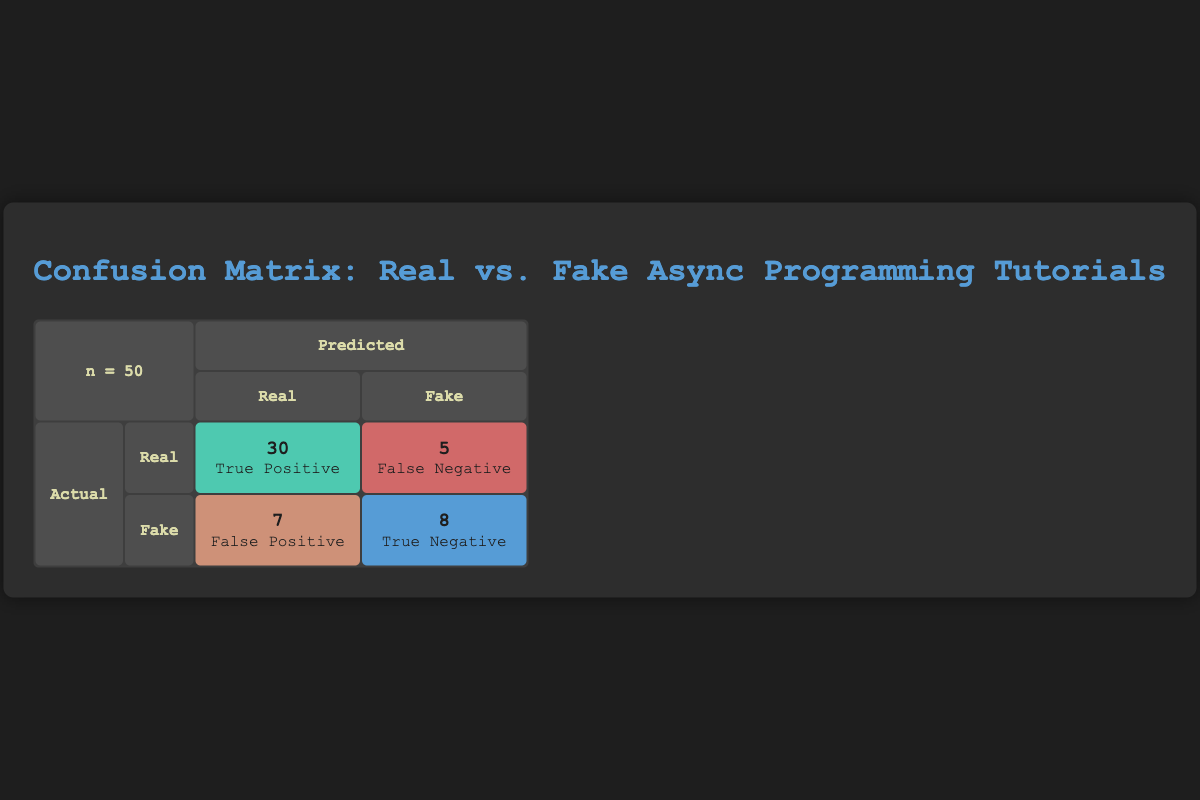What is the number of true positives in the confusion matrix? The table indicates the count of true positives is located in the cell where the actual value is "Real" and the predicted value is also "Real." This cell shows a value of 30.
Answer: 30 What is the number of false negatives? The number of false negatives is found in the cell where the actual value is "Real" but the predicted value is "Fake." The table lists this value as 5.
Answer: 5 What are the total actual fake tutorials? The total number of actual fake tutorials can be calculated by adding the true negatives (8) to the false positives (7) found in the corresponding row for "Fake." Therefore, 8 + 7 = 15.
Answer: 15 Is the number of true negatives greater than the number of false positives? The table shows 8 true negatives and 7 false positives. Since 8 is greater than 7, the statement is true.
Answer: Yes What percentage of actual real tutorials were correctly predicted? The percentage of correctly predicted real tutorials is calculated by taking the number of true positives (30) divided by the total actual real tutorials, which is 35. Thus the calculation is (30/35) * 100 = 85.71%.
Answer: 85.71% What is the total number of tutorials predicted as fake? To find the total predicted as fake, we sum the false positives (7) and true negatives (8) in the row for predicted "Fake." Therefore, the total is 7 + 8 = 15.
Answer: 15 How many tutorials were incorrectly classified as real? The number of incorrectly classified real tutorials includes the false negatives (5) alongside the false positives (7) since these represent misclassified cases. Thus the sum is 5 + 7 = 12.
Answer: 12 What fraction of the total tutorials were true positives? The total number of tutorials is 50 (sum of all values in the table). The number of true positives is 30. Therefore, the fraction is 30/50, which simplifies to 3/5.
Answer: 3/5 What is the ratio of false negatives to true positives? The ratio can be determined by taking the number of false negatives (5) and dividing it by the number of true positives (30). The calculation gives 5:30, which simplifies to 1:6.
Answer: 1:6 